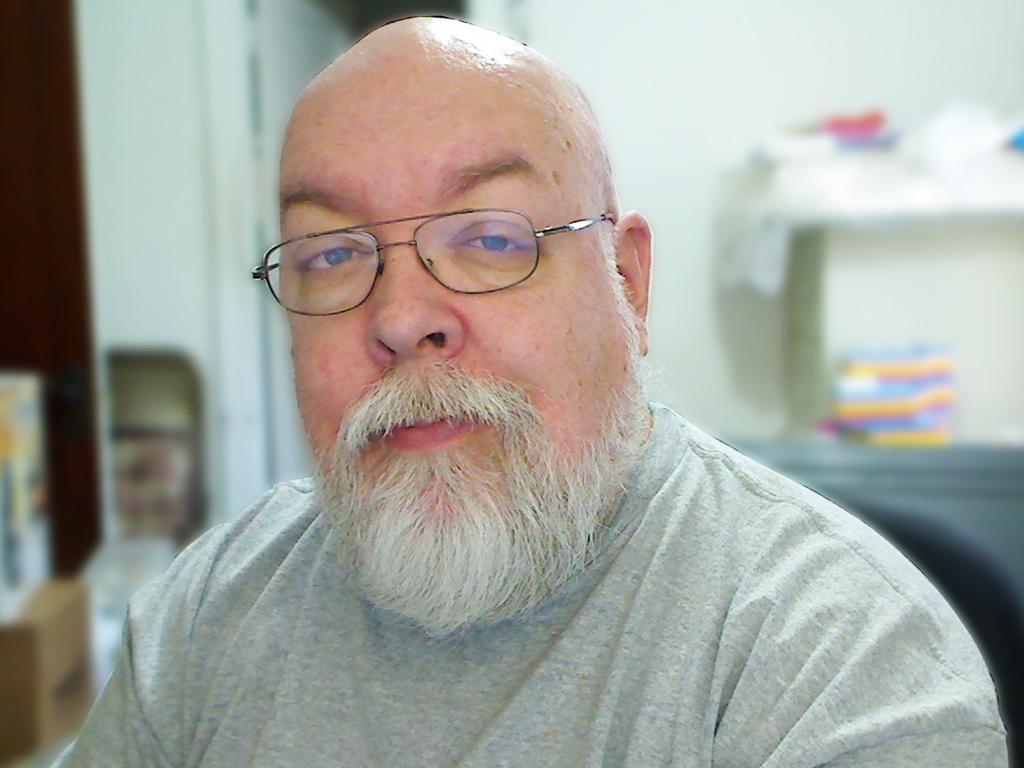How would you summarize this image in a sentence or two? In this image there is a person sitting, there is a person wearing spectacles, there are objects truncated towards the left of the image, there is a chair, there is a door, there are objects truncated towards the right of the image, there is a wall behind the person. 